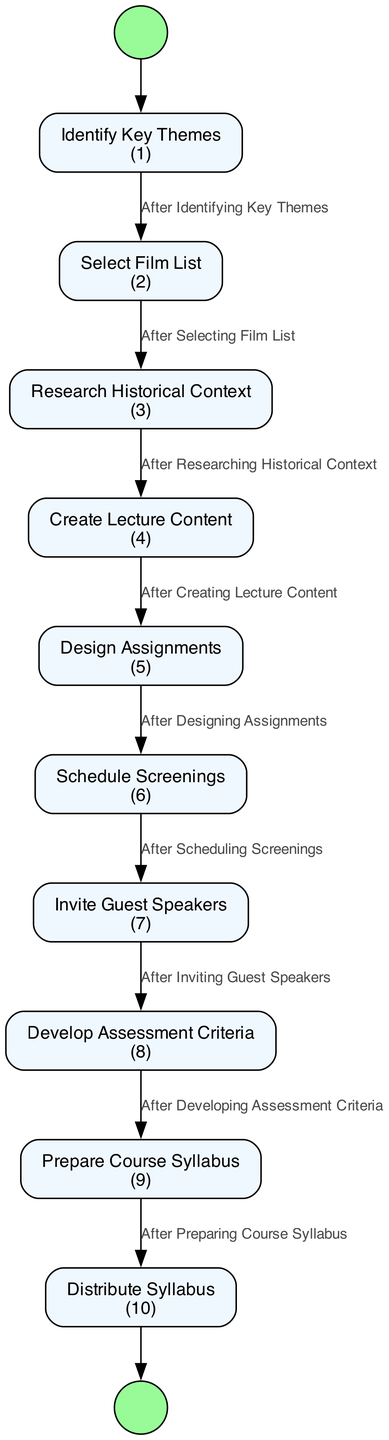What is the first activity in the diagram? The first activity is represented by the starting node which connects to "Identify Key Themes". The starting node indicates that this is the initial step in the process of developing the syllabus.
Answer: Identify Key Themes How many activities are listed in the diagram? By counting the nodes labeled with activities, we see there are ten distinct activities in total in the diagram.
Answer: 10 What is the last activity before the syllabus is distributed? The last activity before distributing the syllabus is "Prepare Course Syllabus", which is the second last step in the flow of the diagram.
Answer: Prepare Course Syllabus Which activity comes immediately after "Design Assignments"? After "Design Assignments", the next activity according to the transition is "Schedule Screenings", indicating a sequential flow in the process.
Answer: Schedule Screenings What is the transition label between "Browse Film List" and "Research Historical Context"? There is no direct transition between "Browse Film List" and "Research Historical Context". Instead, the transition label connecting "Select Film List" to "Research Historical Context" is "After Selecting Film List". This helps clarify the correct order of operations in the process.
Answer: After Selecting Film List What activity involves guest lectures? The activity that involves guest lectures is "Invite Guest Speakers", which directly falls after scheduling screenings in the process.
Answer: Invite Guest Speakers How many transitions are present in the diagram? By counting the arrows that connect each activity, there are nine transitions that illustrate the flow from one activity to the next.
Answer: 9 What is the purpose of the "Develop Assessment Criteria" activity? The purpose of "Develop Assessment Criteria" is to establish guidelines for evaluating student assignments and exams, ensuring consistency and fairness in grading.
Answer: Establish criteria for grading assignments and exams What is the final activity in the diagram? The final activity shown in the diagram is "Distribute Syllabus", marking the completion of the syllabus development process where students receive their course materials.
Answer: Distribute Syllabus 